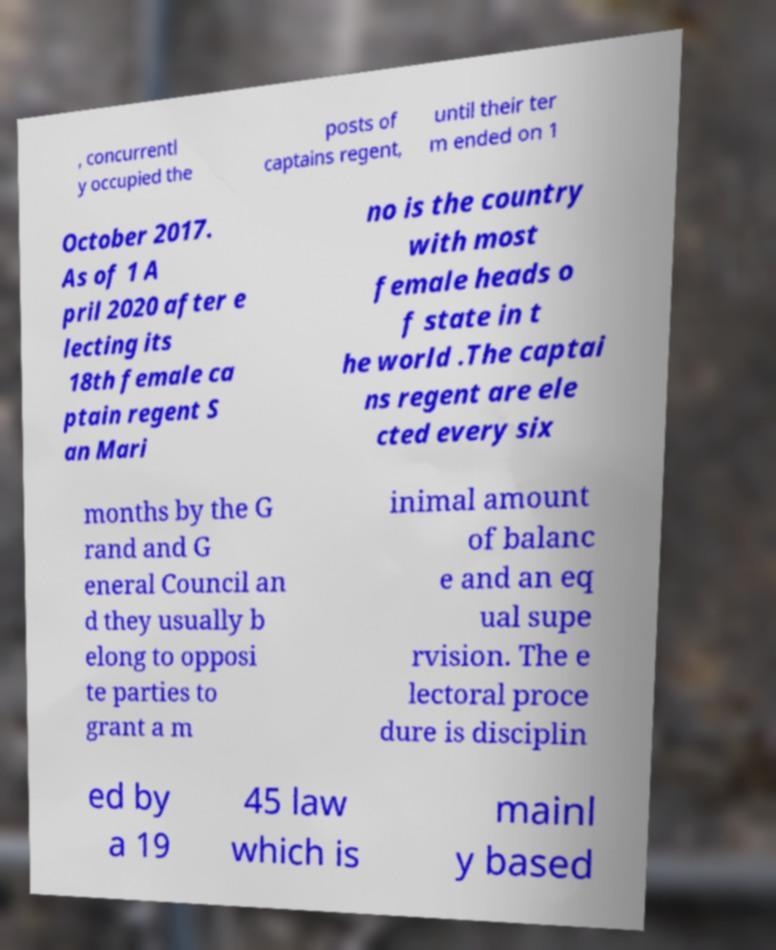Can you read and provide the text displayed in the image?This photo seems to have some interesting text. Can you extract and type it out for me? , concurrentl y occupied the posts of captains regent, until their ter m ended on 1 October 2017. As of 1 A pril 2020 after e lecting its 18th female ca ptain regent S an Mari no is the country with most female heads o f state in t he world .The captai ns regent are ele cted every six months by the G rand and G eneral Council an d they usually b elong to opposi te parties to grant a m inimal amount of balanc e and an eq ual supe rvision. The e lectoral proce dure is disciplin ed by a 19 45 law which is mainl y based 